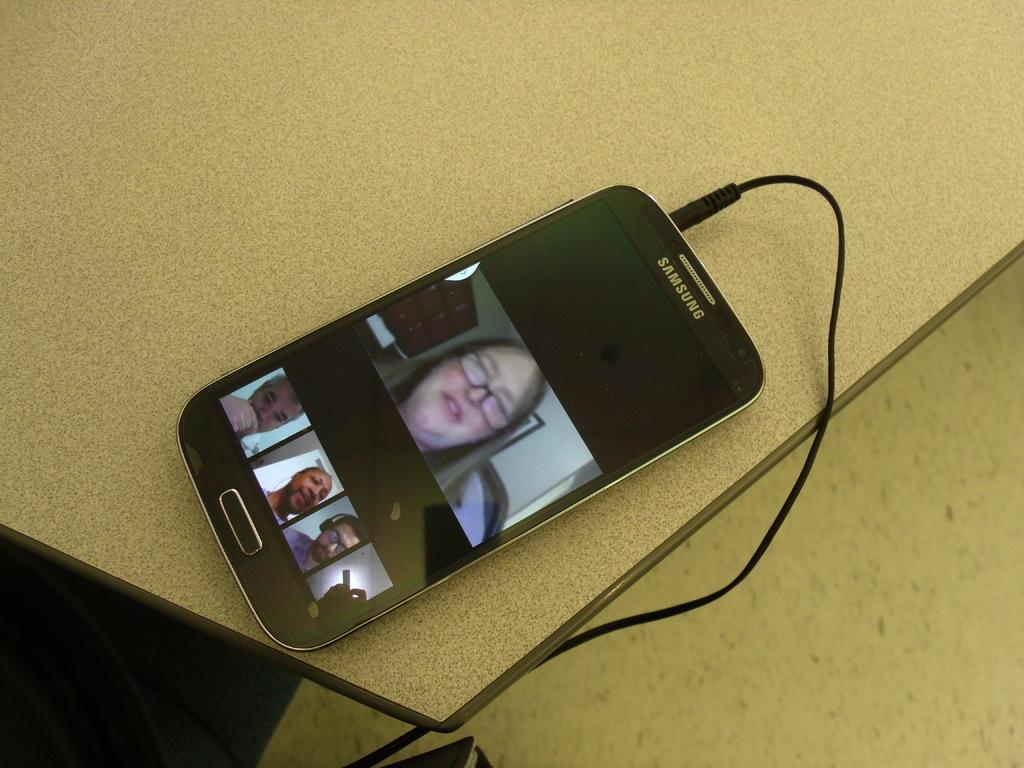<image>
Create a compact narrative representing the image presented. A video of a lady is seen on a Samsung cell phone. 